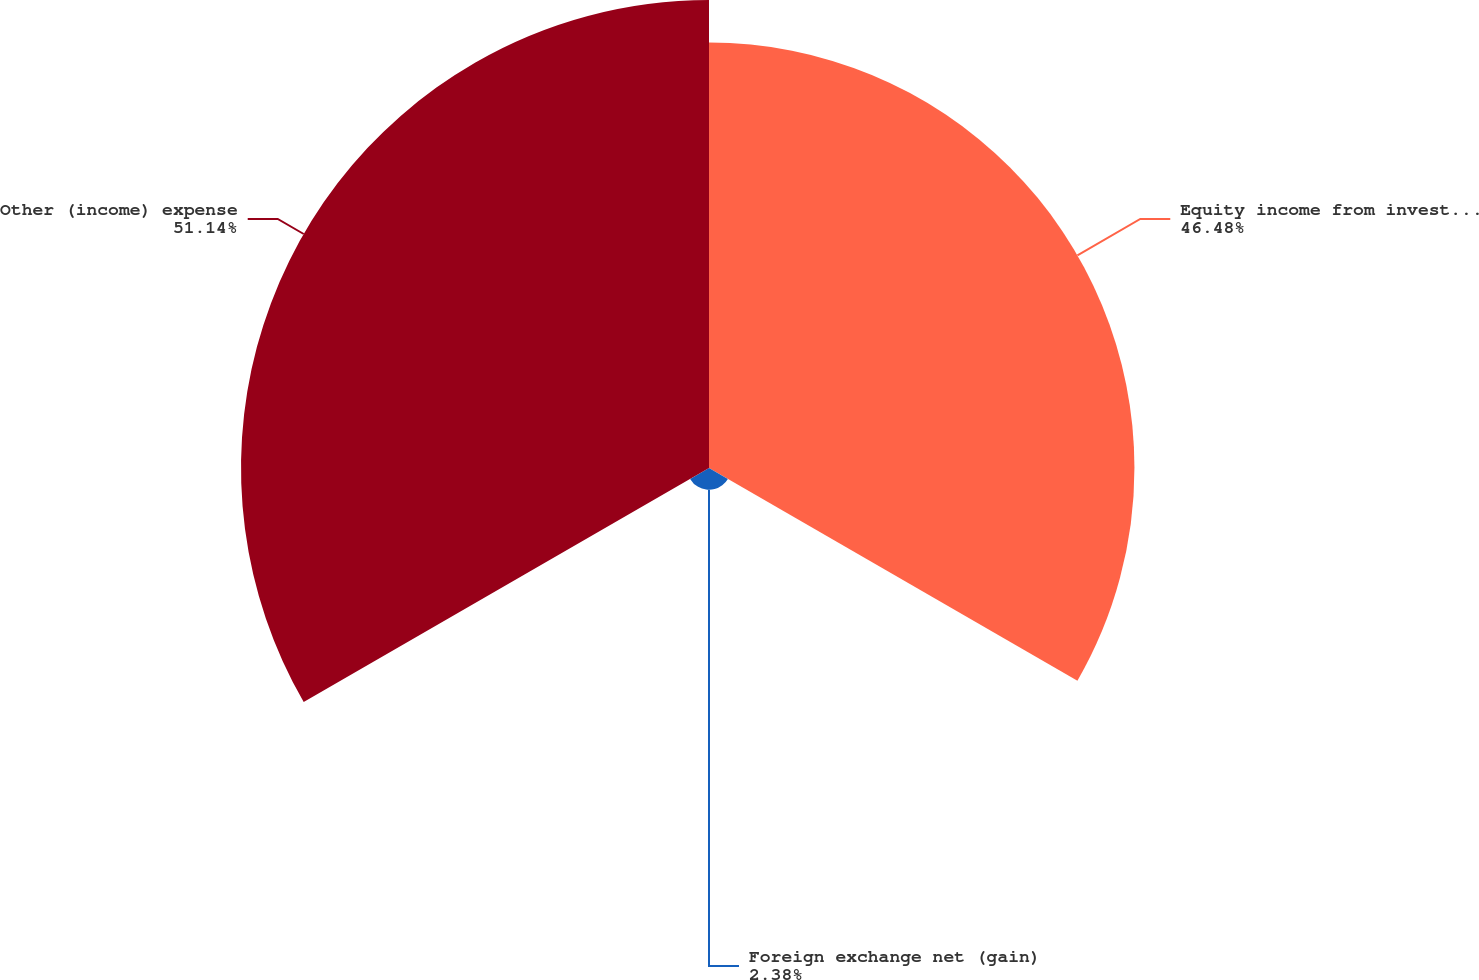Convert chart to OTSL. <chart><loc_0><loc_0><loc_500><loc_500><pie_chart><fcel>Equity income from investments<fcel>Foreign exchange net (gain)<fcel>Other (income) expense<nl><fcel>46.48%<fcel>2.38%<fcel>51.13%<nl></chart> 